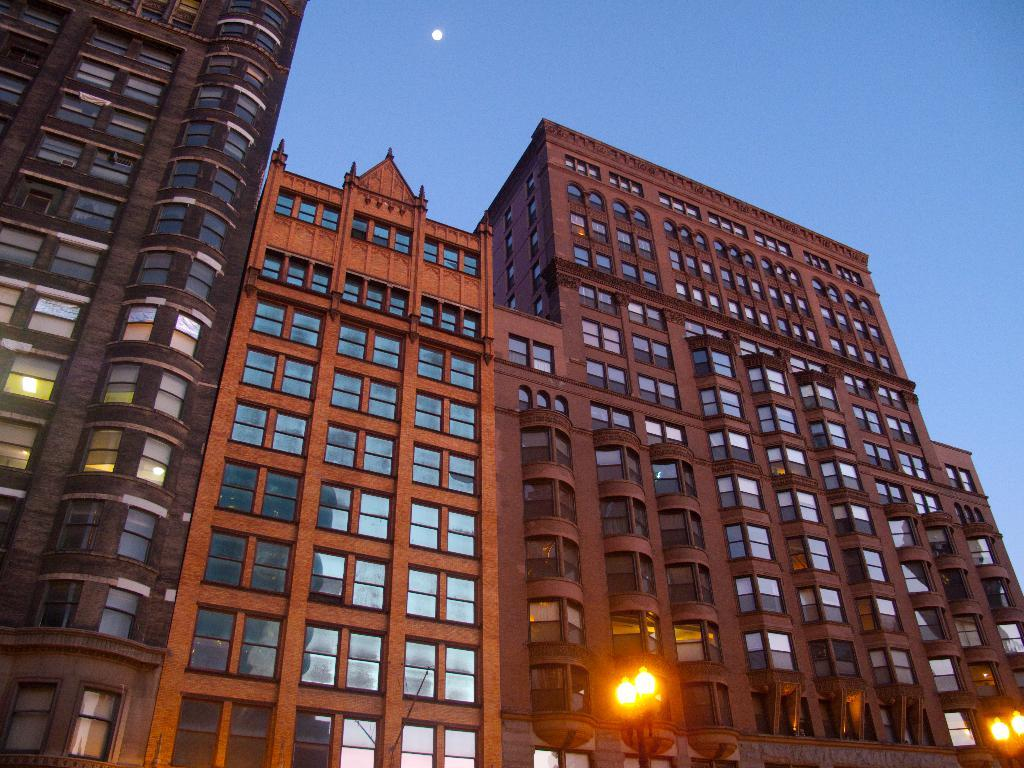What type of structures are present in the image? There are buildings in the image. What colors are the buildings? The buildings are in gray and cream color. What is visible in the background of the image? The background of the image includes the moon. What color is the moon? The moon is in white color. What color is the sky in the image? The sky is in blue color. What type of cloth is draped over the buildings in the image? There is no cloth draped over the buildings in the image; the buildings are in gray and cream color. 